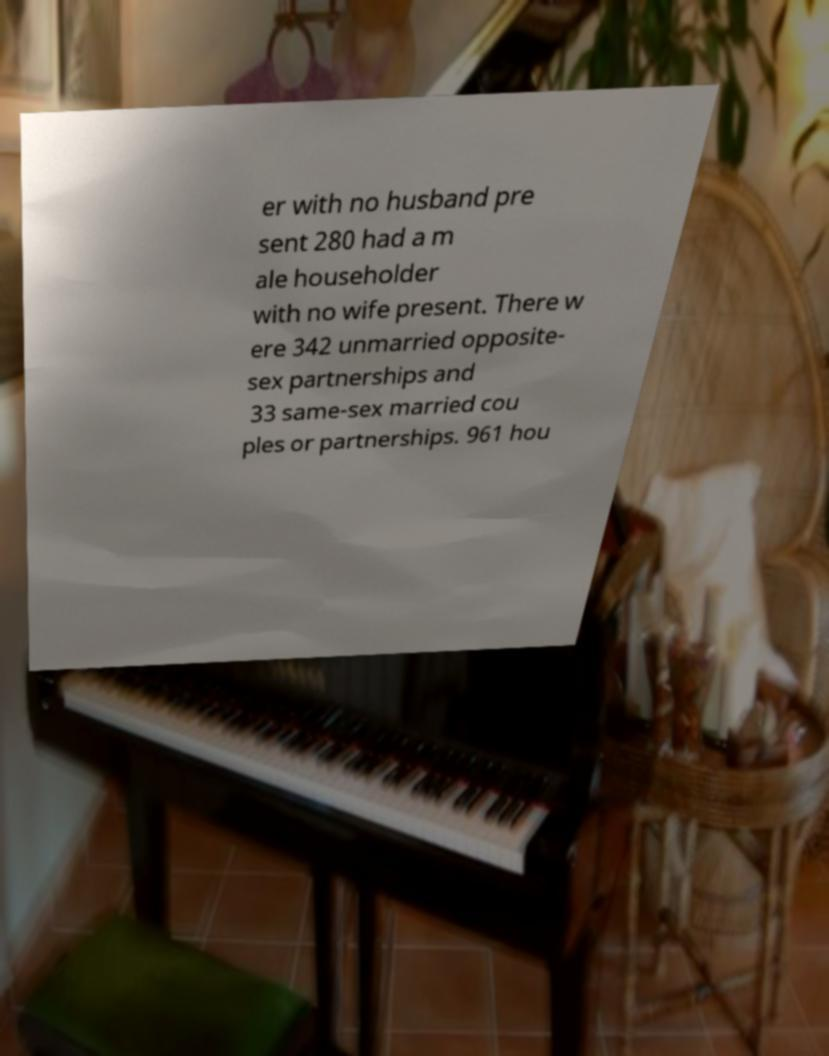Could you extract and type out the text from this image? er with no husband pre sent 280 had a m ale householder with no wife present. There w ere 342 unmarried opposite- sex partnerships and 33 same-sex married cou ples or partnerships. 961 hou 